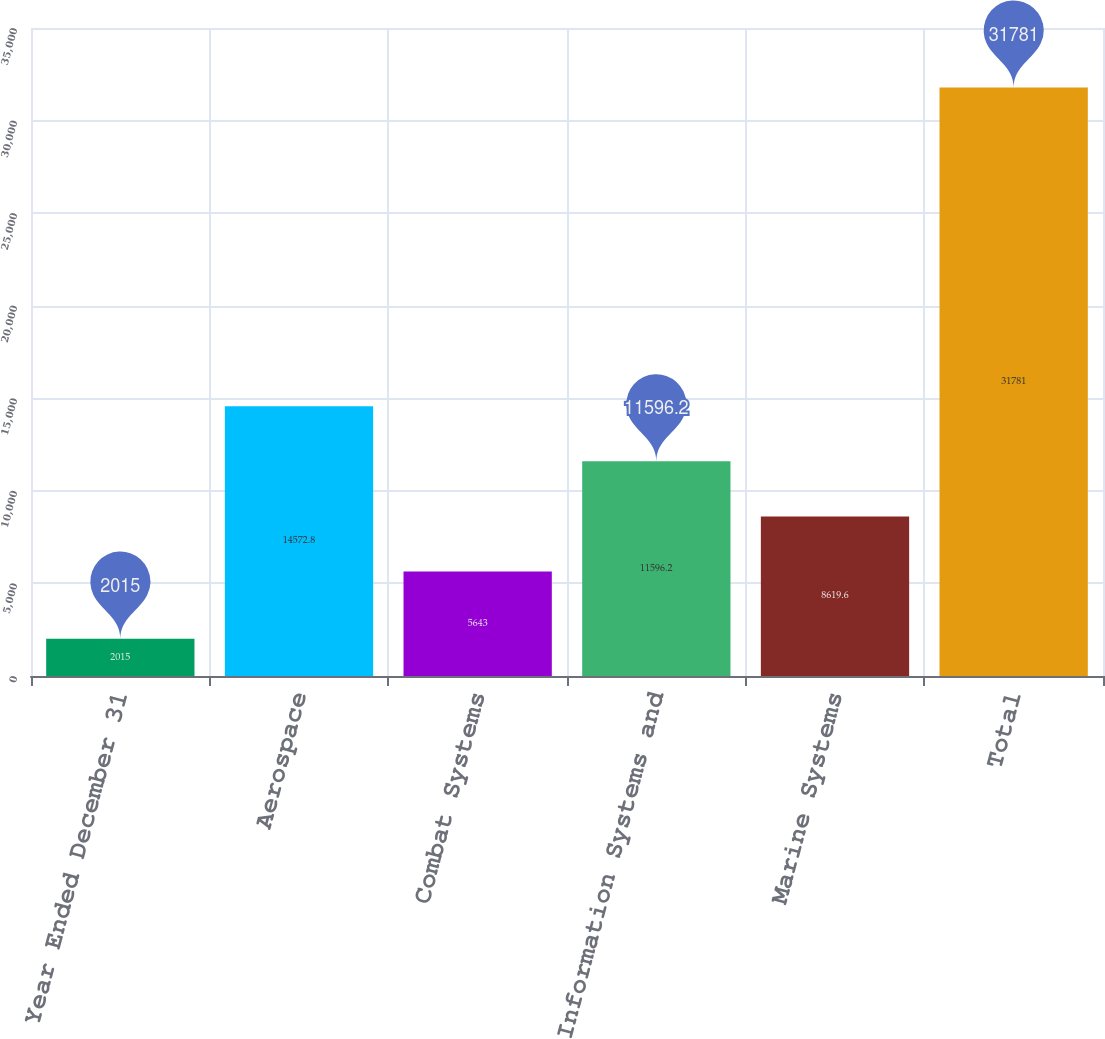Convert chart. <chart><loc_0><loc_0><loc_500><loc_500><bar_chart><fcel>Year Ended December 31<fcel>Aerospace<fcel>Combat Systems<fcel>Information Systems and<fcel>Marine Systems<fcel>Total<nl><fcel>2015<fcel>14572.8<fcel>5643<fcel>11596.2<fcel>8619.6<fcel>31781<nl></chart> 